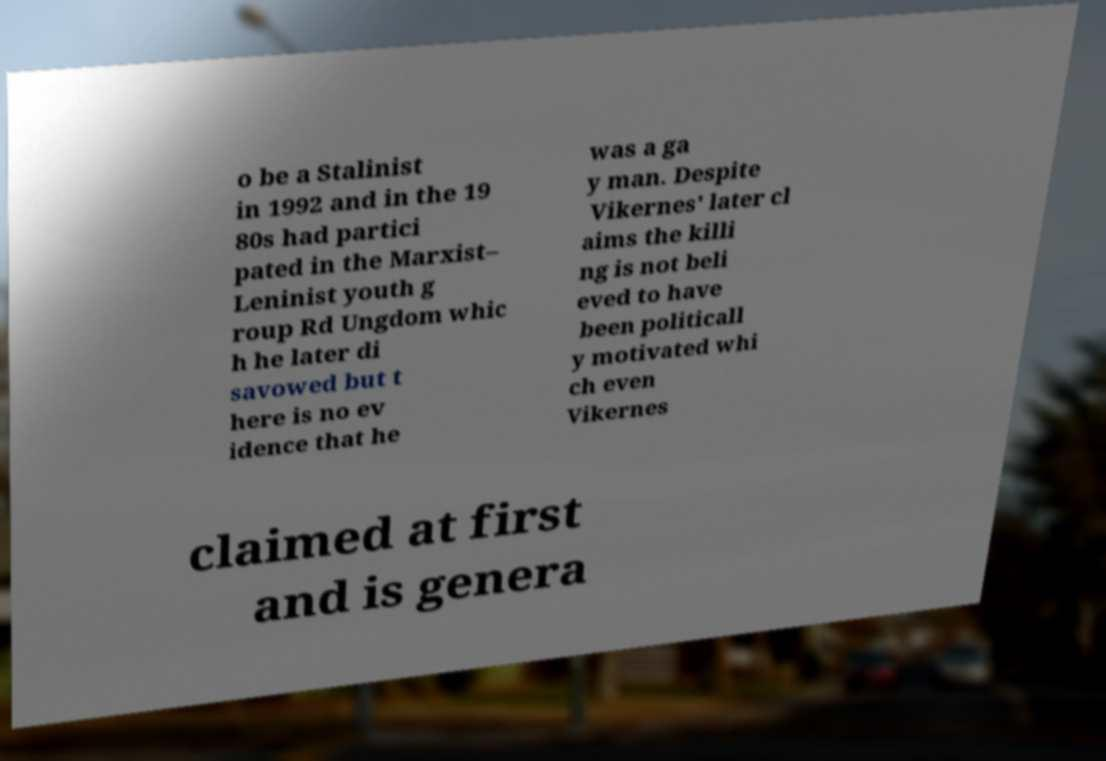Please identify and transcribe the text found in this image. o be a Stalinist in 1992 and in the 19 80s had partici pated in the Marxist– Leninist youth g roup Rd Ungdom whic h he later di savowed but t here is no ev idence that he was a ga y man. Despite Vikernes' later cl aims the killi ng is not beli eved to have been politicall y motivated whi ch even Vikernes claimed at first and is genera 